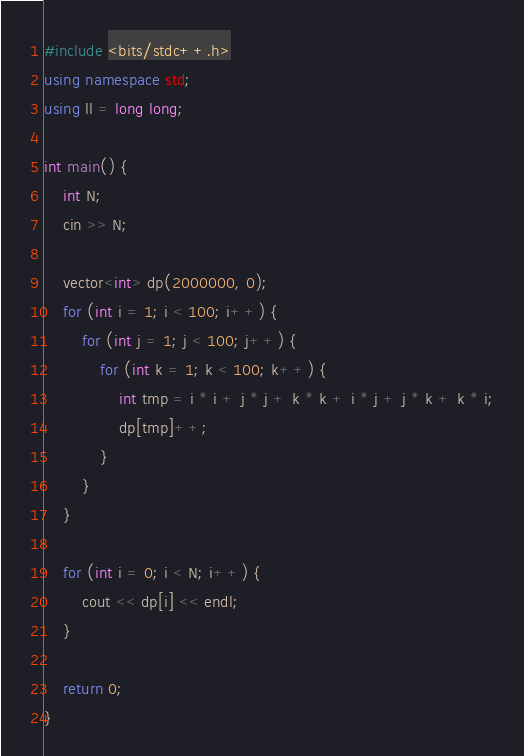<code> <loc_0><loc_0><loc_500><loc_500><_C++_>#include <bits/stdc++.h>
using namespace std;
using ll = long long;

int main() {
	int N;
	cin >> N;

	vector<int> dp(2000000, 0);
	for (int i = 1; i < 100; i++) {
		for (int j = 1; j < 100; j++) {
			for (int k = 1; k < 100; k++) {
				int tmp = i * i + j * j + k * k + i * j + j * k + k * i;
				dp[tmp]++;
			}
		}
	}

	for (int i = 0; i < N; i++) {
		cout << dp[i] << endl;
	}

	return 0;
}</code> 